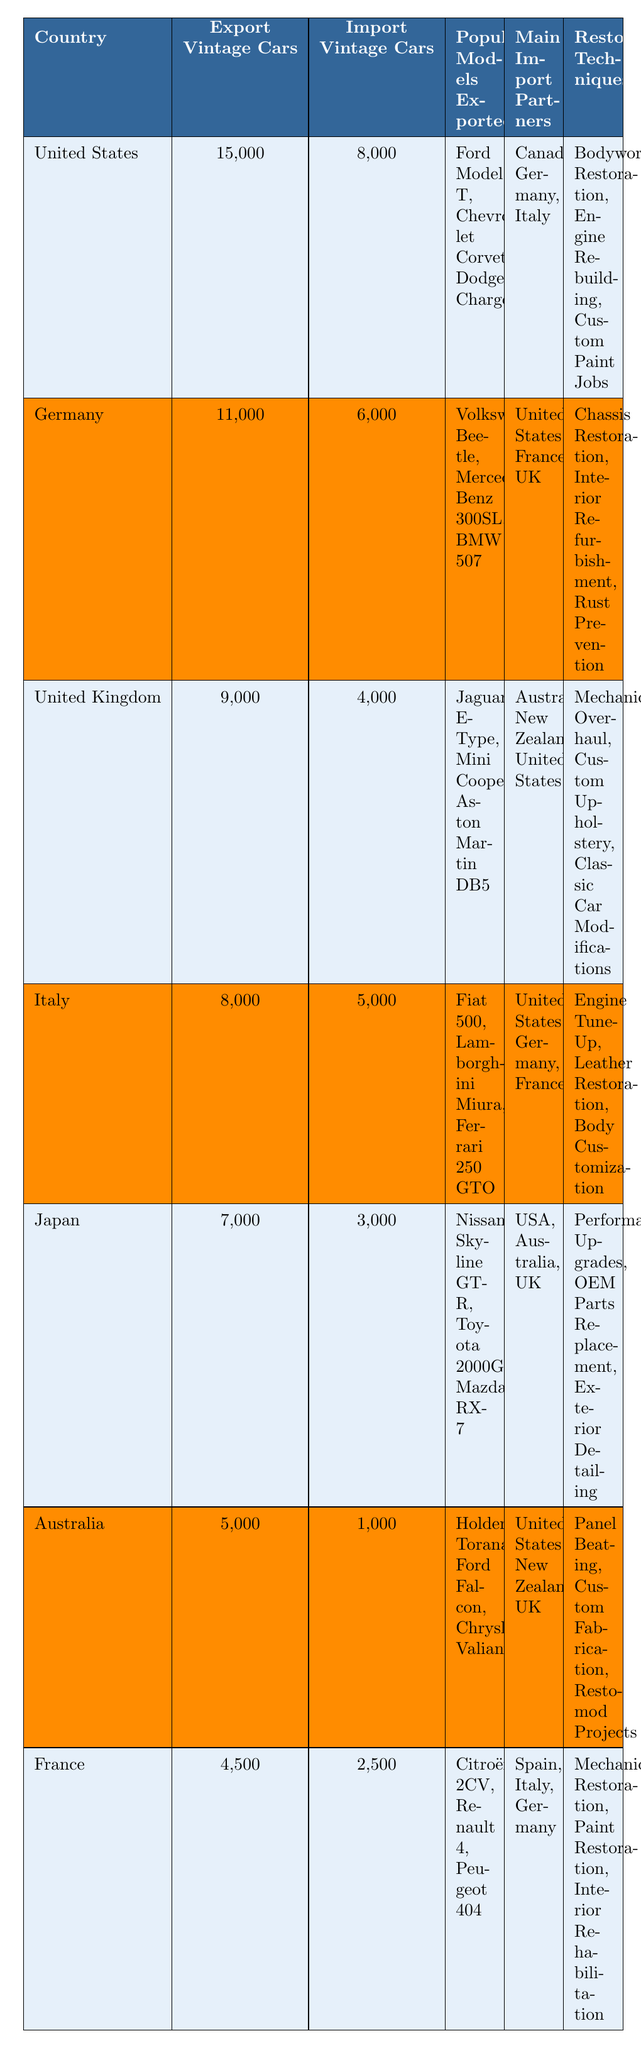What country exports the most vintage cars? According to the table, the United States exports the highest number of vintage cars at 15,000 units.
Answer: United States How many vintage cars does Germany import? From the table, Germany imports 6,000 vintage cars.
Answer: 6,000 Which country is a main import partner for both Germany and Italy? Both Germany and Italy list the United States as a main import partner, as seen in the table.
Answer: United States What is the total number of vintage cars exported by Japan and Australia combined? Japan exports 7,000 cars and Australia exports 5,000 cars; therefore, the total is 7,000 + 5,000 = 12,000.
Answer: 12,000 Which country listed has the fewest imports of vintage cars? Australia has the fewest imports, with only 1,000 vintage cars imported.
Answer: Australia Are the restoration techniques in Germany focused on mechanical aspects? Yes, the restoration techniques in Germany include chassis restoration, interior refurbishment, and rust prevention, all of which are mechanical aspects.
Answer: Yes What is the difference between the number of vintage cars exported by the United States and the United Kingdom? The United States exports 15,000 vintage cars, and the United Kingdom exports 9,000. The difference is 15,000 - 9,000 = 6,000.
Answer: 6,000 Is it true that Italy exports more vintage cars than France? Yes, Italy exports 8,000 vintage cars while France exports 4,500, so it is true.
Answer: True What are the three most popular models exported by Japan? The most popular models exported by Japan are the Nissan Skyline GT-R, Toyota 2000GT, and Mazda RX-7, as seen in the table.
Answer: Nissan Skyline GT-R, Toyota 2000GT, Mazda RX-7 Which country has the highest export to import ratio for vintage cars? To find this, we calculate the ratio for each country: United States (15,000/8,000 = 1.875), Germany (11,000/6,000 = 1.833), United Kingdom (9,000/4,000 = 2.25), Italy (8,000/5,000 = 1.6), Japan (7,000/3,000 = 2.33), Australia (5,000/1,000 = 5), and France (4,500/2,500 = 1.8). Australia has the highest ratio of 5.
Answer: Australia 